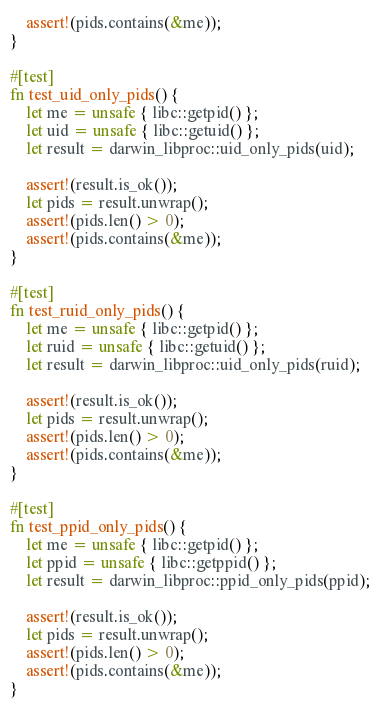<code> <loc_0><loc_0><loc_500><loc_500><_Rust_>    assert!(pids.contains(&me));
}

#[test]
fn test_uid_only_pids() {
    let me = unsafe { libc::getpid() };
    let uid = unsafe { libc::getuid() };
    let result = darwin_libproc::uid_only_pids(uid);

    assert!(result.is_ok());
    let pids = result.unwrap();
    assert!(pids.len() > 0);
    assert!(pids.contains(&me));
}

#[test]
fn test_ruid_only_pids() {
    let me = unsafe { libc::getpid() };
    let ruid = unsafe { libc::getuid() };
    let result = darwin_libproc::uid_only_pids(ruid);

    assert!(result.is_ok());
    let pids = result.unwrap();
    assert!(pids.len() > 0);
    assert!(pids.contains(&me));
}

#[test]
fn test_ppid_only_pids() {
    let me = unsafe { libc::getpid() };
    let ppid = unsafe { libc::getppid() };
    let result = darwin_libproc::ppid_only_pids(ppid);

    assert!(result.is_ok());
    let pids = result.unwrap();
    assert!(pids.len() > 0);
    assert!(pids.contains(&me));
}
</code> 